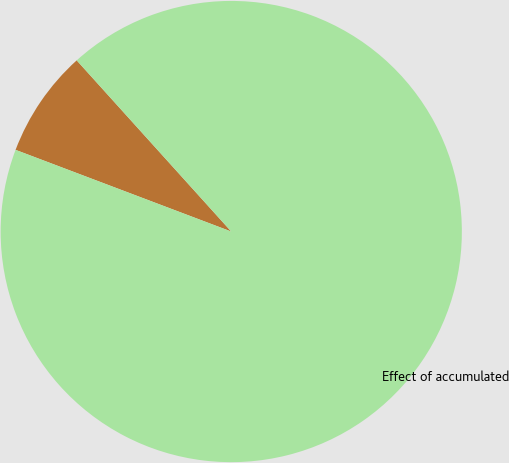Convert chart. <chart><loc_0><loc_0><loc_500><loc_500><pie_chart><ecel><fcel>Effect of accumulated<nl><fcel>7.55%<fcel>92.45%<nl></chart> 